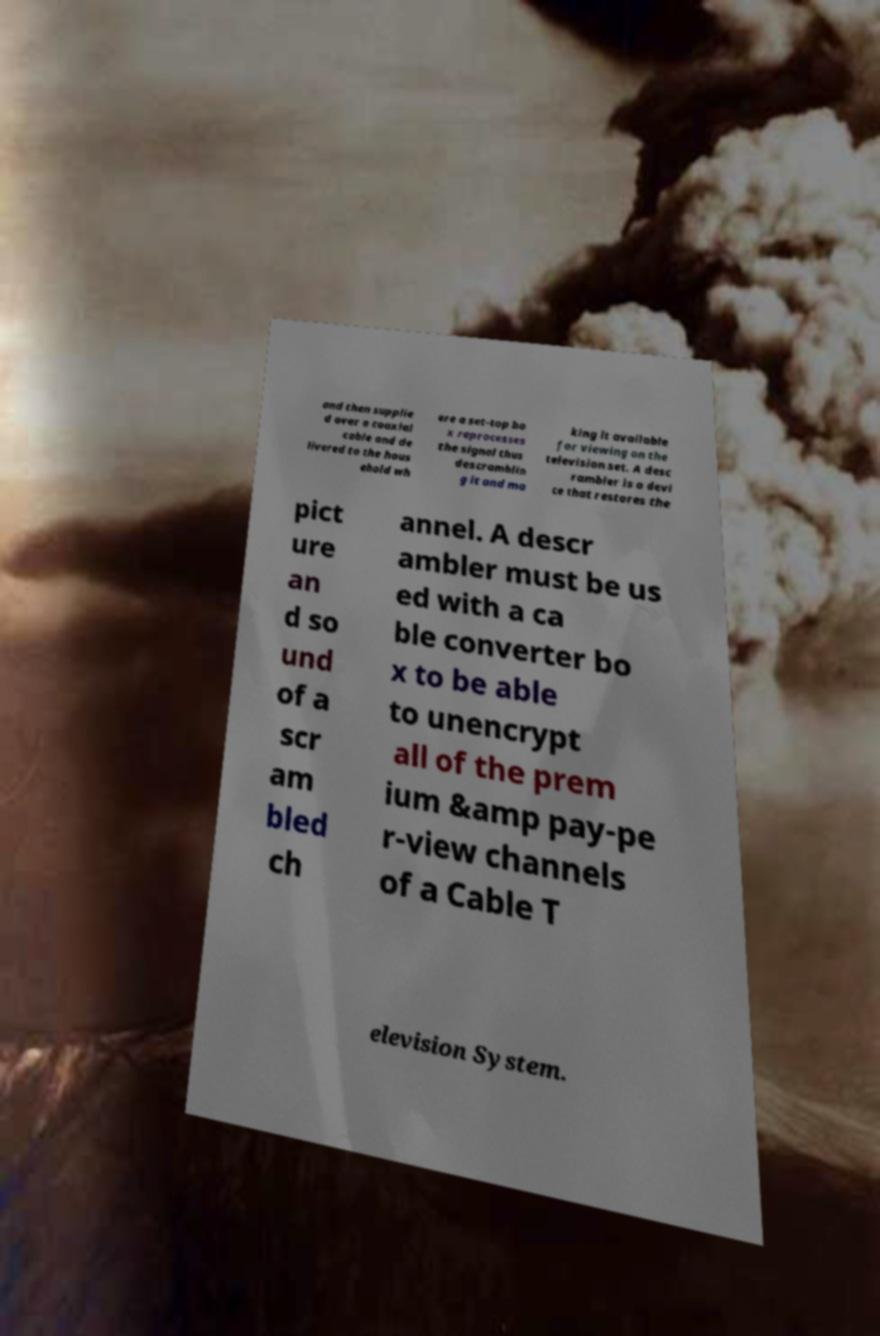Could you assist in decoding the text presented in this image and type it out clearly? and then supplie d over a coaxial cable and de livered to the hous ehold wh ere a set-top bo x reprocesses the signal thus descramblin g it and ma king it available for viewing on the television set. A desc rambler is a devi ce that restores the pict ure an d so und of a scr am bled ch annel. A descr ambler must be us ed with a ca ble converter bo x to be able to unencrypt all of the prem ium &amp pay-pe r-view channels of a Cable T elevision System. 